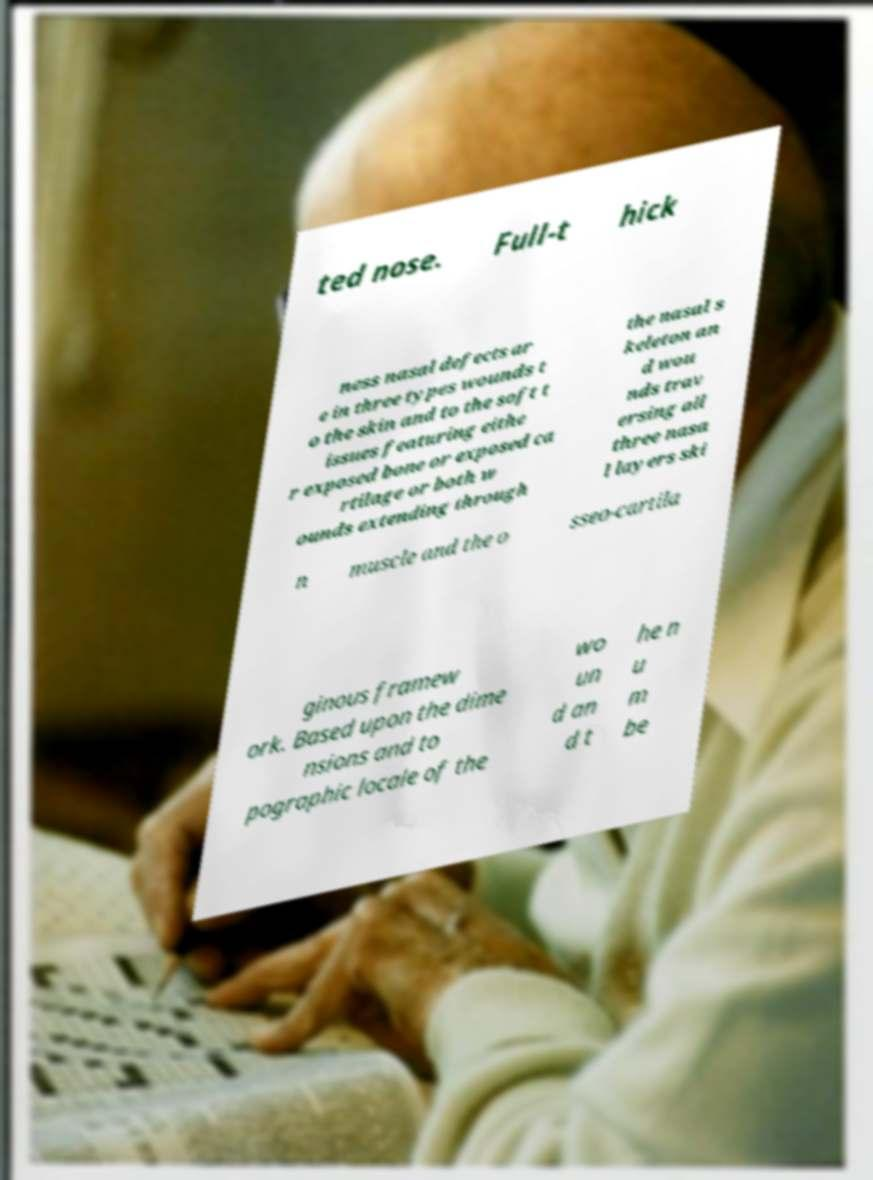Can you accurately transcribe the text from the provided image for me? ted nose. Full-t hick ness nasal defects ar e in three types wounds t o the skin and to the soft t issues featuring eithe r exposed bone or exposed ca rtilage or both w ounds extending through the nasal s keleton an d wou nds trav ersing all three nasa l layers ski n muscle and the o sseo-cartila ginous framew ork. Based upon the dime nsions and to pographic locale of the wo un d an d t he n u m be 